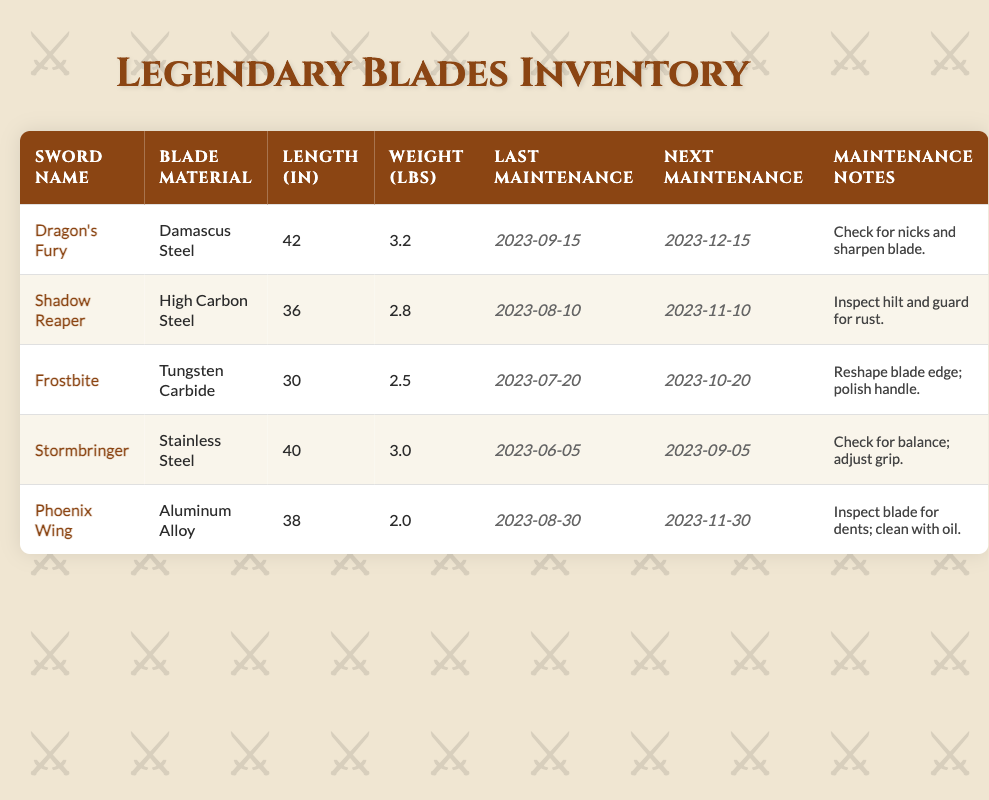What is the blade material of 'Dragon's Fury'? The table lists the blade material for 'Dragon's Fury' in the second column, which shows it is made of Damascus Steel.
Answer: Damascus Steel When is the next maintenance due for 'Frostbite'? The next maintenance date for 'Frostbite' can be found under the "Next Maintenance" column, where it indicates that the next maintenance is due on 2023-10-20.
Answer: 2023-10-20 Which sword weighs the most and how much does it weigh? By comparing the weights in the "Weight (lbs)" column, 'Dragon's Fury' has the highest weight at 3.2 pounds.
Answer: Dragon's Fury, 3.2 pounds Is the maintenance note for 'Shadow Reaper' related to the blade itself? The maintenance note for 'Shadow Reaper' specifies inspecting the hilt and guard for rust, which does not pertain to the blade but rather to other components.
Answer: No What is the average length of the swords in the inventory? The lengths of the swords are 42, 36, 30, 40, and 38 inches. Summing these gives 186 inches. There are 5 swords, so the average length is 186/5 = 37.2 inches.
Answer: 37.2 inches Which sword has the next maintenance date after 'Stormbringer'? Checking the "Next Maintenance" column, 'Stormbringer' is scheduled for maintenance on 2023-09-05. The next sword is 'Dragon's Fury', scheduled for 2023-12-15.
Answer: Dragon's Fury Does any sword need maintenance before the end of November 2023? Looking through the "Next Maintenance" column, 'Frostbite' (2023-10-20) and 'Shadow Reaper' (2023-11-10) both require maintenance before the end of November.
Answer: Yes How many swords in the inventory have a blade length greater than 36 inches? Checking the lengths of all swords, 'Dragon's Fury' (42 in), 'Stormbringer' (40 in), and 'Phoenix Wing' (38 in) are all greater than 36 inches. This totals 3 swords.
Answer: 3 